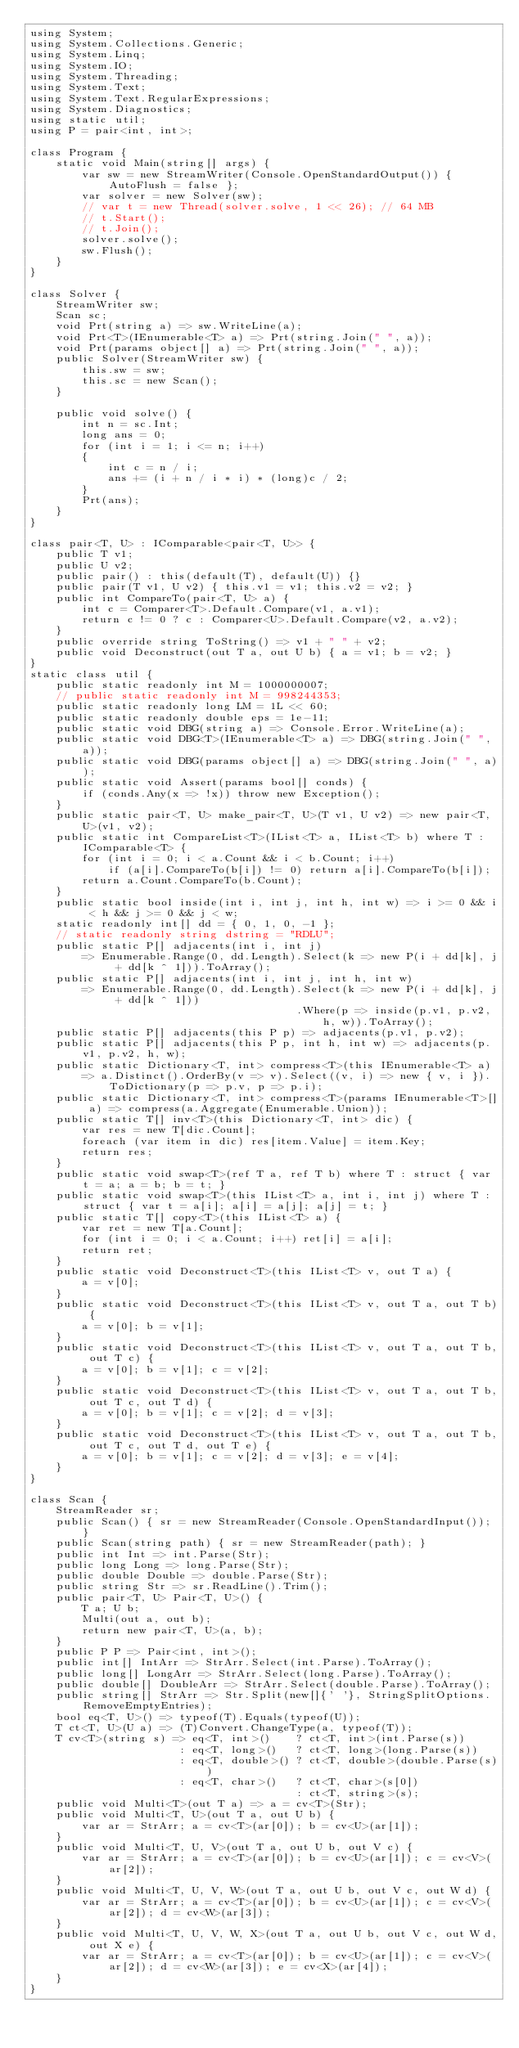<code> <loc_0><loc_0><loc_500><loc_500><_C#_>using System;
using System.Collections.Generic;
using System.Linq;
using System.IO;
using System.Threading;
using System.Text;
using System.Text.RegularExpressions;
using System.Diagnostics;
using static util;
using P = pair<int, int>;

class Program {
    static void Main(string[] args) {
        var sw = new StreamWriter(Console.OpenStandardOutput()) { AutoFlush = false };
        var solver = new Solver(sw);
        // var t = new Thread(solver.solve, 1 << 26); // 64 MB
        // t.Start();
        // t.Join();
        solver.solve();
        sw.Flush();
    }
}

class Solver {
    StreamWriter sw;
    Scan sc;
    void Prt(string a) => sw.WriteLine(a);
    void Prt<T>(IEnumerable<T> a) => Prt(string.Join(" ", a));
    void Prt(params object[] a) => Prt(string.Join(" ", a));
    public Solver(StreamWriter sw) {
        this.sw = sw;
        this.sc = new Scan();
    }

    public void solve() {
        int n = sc.Int;
        long ans = 0;
        for (int i = 1; i <= n; i++)
        {
            int c = n / i;
            ans += (i + n / i * i) * (long)c / 2;
        }
        Prt(ans);
    }
}

class pair<T, U> : IComparable<pair<T, U>> {
    public T v1;
    public U v2;
    public pair() : this(default(T), default(U)) {}
    public pair(T v1, U v2) { this.v1 = v1; this.v2 = v2; }
    public int CompareTo(pair<T, U> a) {
        int c = Comparer<T>.Default.Compare(v1, a.v1);
        return c != 0 ? c : Comparer<U>.Default.Compare(v2, a.v2);
    }
    public override string ToString() => v1 + " " + v2;
    public void Deconstruct(out T a, out U b) { a = v1; b = v2; }
}
static class util {
    public static readonly int M = 1000000007;
    // public static readonly int M = 998244353;
    public static readonly long LM = 1L << 60;
    public static readonly double eps = 1e-11;
    public static void DBG(string a) => Console.Error.WriteLine(a);
    public static void DBG<T>(IEnumerable<T> a) => DBG(string.Join(" ", a));
    public static void DBG(params object[] a) => DBG(string.Join(" ", a));
    public static void Assert(params bool[] conds) {
        if (conds.Any(x => !x)) throw new Exception();
    }
    public static pair<T, U> make_pair<T, U>(T v1, U v2) => new pair<T, U>(v1, v2);
    public static int CompareList<T>(IList<T> a, IList<T> b) where T : IComparable<T> {
        for (int i = 0; i < a.Count && i < b.Count; i++)
            if (a[i].CompareTo(b[i]) != 0) return a[i].CompareTo(b[i]);
        return a.Count.CompareTo(b.Count);
    }
    public static bool inside(int i, int j, int h, int w) => i >= 0 && i < h && j >= 0 && j < w;
    static readonly int[] dd = { 0, 1, 0, -1 };
    // static readonly string dstring = "RDLU";
    public static P[] adjacents(int i, int j)
        => Enumerable.Range(0, dd.Length).Select(k => new P(i + dd[k], j + dd[k ^ 1])).ToArray();
    public static P[] adjacents(int i, int j, int h, int w)
        => Enumerable.Range(0, dd.Length).Select(k => new P(i + dd[k], j + dd[k ^ 1]))
                                         .Where(p => inside(p.v1, p.v2, h, w)).ToArray();
    public static P[] adjacents(this P p) => adjacents(p.v1, p.v2);
    public static P[] adjacents(this P p, int h, int w) => adjacents(p.v1, p.v2, h, w);
    public static Dictionary<T, int> compress<T>(this IEnumerable<T> a)
        => a.Distinct().OrderBy(v => v).Select((v, i) => new { v, i }).ToDictionary(p => p.v, p => p.i);
    public static Dictionary<T, int> compress<T>(params IEnumerable<T>[] a) => compress(a.Aggregate(Enumerable.Union));
    public static T[] inv<T>(this Dictionary<T, int> dic) {
        var res = new T[dic.Count];
        foreach (var item in dic) res[item.Value] = item.Key;
        return res;
    }
    public static void swap<T>(ref T a, ref T b) where T : struct { var t = a; a = b; b = t; }
    public static void swap<T>(this IList<T> a, int i, int j) where T : struct { var t = a[i]; a[i] = a[j]; a[j] = t; }
    public static T[] copy<T>(this IList<T> a) {
        var ret = new T[a.Count];
        for (int i = 0; i < a.Count; i++) ret[i] = a[i];
        return ret;
    }
    public static void Deconstruct<T>(this IList<T> v, out T a) {
        a = v[0];
    }
    public static void Deconstruct<T>(this IList<T> v, out T a, out T b) {
        a = v[0]; b = v[1];
    }
    public static void Deconstruct<T>(this IList<T> v, out T a, out T b, out T c) {
        a = v[0]; b = v[1]; c = v[2];
    }
    public static void Deconstruct<T>(this IList<T> v, out T a, out T b, out T c, out T d) {
        a = v[0]; b = v[1]; c = v[2]; d = v[3];
    }
    public static void Deconstruct<T>(this IList<T> v, out T a, out T b, out T c, out T d, out T e) {
        a = v[0]; b = v[1]; c = v[2]; d = v[3]; e = v[4];
    }
}

class Scan {
    StreamReader sr;
    public Scan() { sr = new StreamReader(Console.OpenStandardInput()); }
    public Scan(string path) { sr = new StreamReader(path); }
    public int Int => int.Parse(Str);
    public long Long => long.Parse(Str);
    public double Double => double.Parse(Str);
    public string Str => sr.ReadLine().Trim();
    public pair<T, U> Pair<T, U>() {
        T a; U b;
        Multi(out a, out b);
        return new pair<T, U>(a, b);
    }
    public P P => Pair<int, int>();
    public int[] IntArr => StrArr.Select(int.Parse).ToArray();
    public long[] LongArr => StrArr.Select(long.Parse).ToArray();
    public double[] DoubleArr => StrArr.Select(double.Parse).ToArray();
    public string[] StrArr => Str.Split(new[]{' '}, StringSplitOptions.RemoveEmptyEntries);
    bool eq<T, U>() => typeof(T).Equals(typeof(U));
    T ct<T, U>(U a) => (T)Convert.ChangeType(a, typeof(T));
    T cv<T>(string s) => eq<T, int>()    ? ct<T, int>(int.Parse(s))
                       : eq<T, long>()   ? ct<T, long>(long.Parse(s))
                       : eq<T, double>() ? ct<T, double>(double.Parse(s))
                       : eq<T, char>()   ? ct<T, char>(s[0])
                                         : ct<T, string>(s);
    public void Multi<T>(out T a) => a = cv<T>(Str);
    public void Multi<T, U>(out T a, out U b) {
        var ar = StrArr; a = cv<T>(ar[0]); b = cv<U>(ar[1]);
    }
    public void Multi<T, U, V>(out T a, out U b, out V c) {
        var ar = StrArr; a = cv<T>(ar[0]); b = cv<U>(ar[1]); c = cv<V>(ar[2]);
    }
    public void Multi<T, U, V, W>(out T a, out U b, out V c, out W d) {
        var ar = StrArr; a = cv<T>(ar[0]); b = cv<U>(ar[1]); c = cv<V>(ar[2]); d = cv<W>(ar[3]);
    }
    public void Multi<T, U, V, W, X>(out T a, out U b, out V c, out W d, out X e) {
        var ar = StrArr; a = cv<T>(ar[0]); b = cv<U>(ar[1]); c = cv<V>(ar[2]); d = cv<W>(ar[3]); e = cv<X>(ar[4]);
    }
}
</code> 